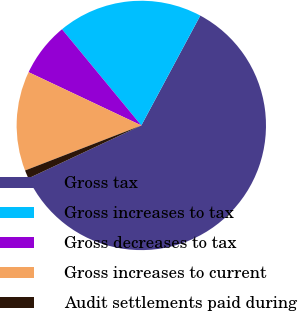Convert chart. <chart><loc_0><loc_0><loc_500><loc_500><pie_chart><fcel>Gross tax<fcel>Gross increases to tax<fcel>Gross decreases to tax<fcel>Gross increases to current<fcel>Audit settlements paid during<nl><fcel>60.19%<fcel>18.82%<fcel>7.0%<fcel>12.91%<fcel>1.09%<nl></chart> 